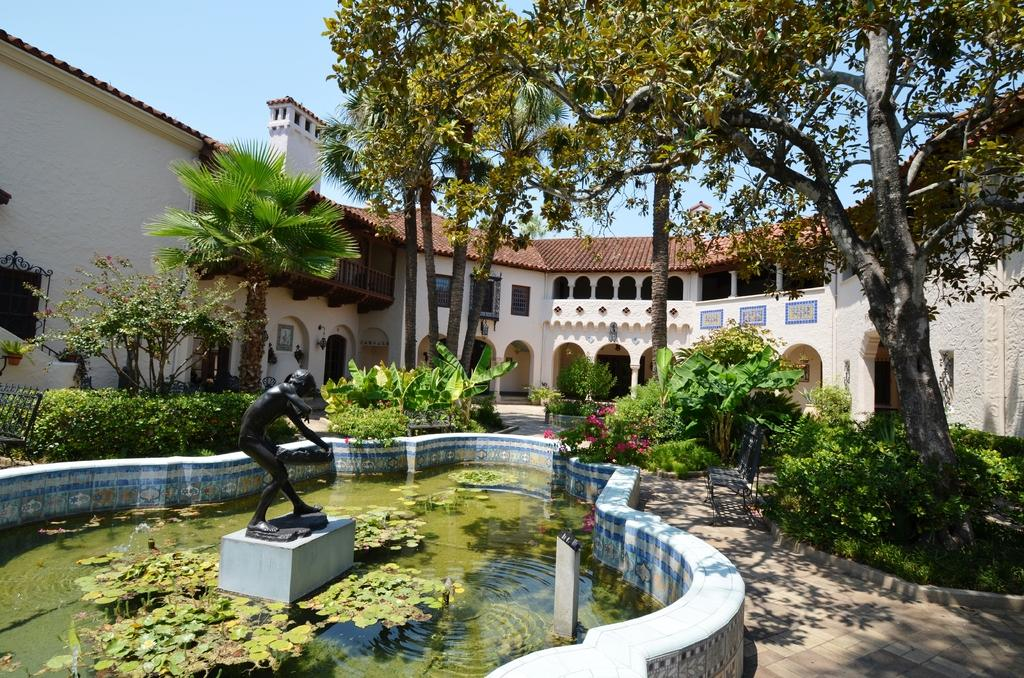What type of structure is visible in the image? There is a house in the image. What architectural features can be seen on the house? There are pillars, walls, windows, and railings visible on the house. What other objects or elements are present in the image? There are trees, plants, a bench, a statue, and water fountains in the image. What can be seen in the background of the image? The sky is visible in the background of the image. How many beds are visible in the image? There are no beds present in the image. What type of flame can be seen coming from the statue's finger in the image? There is no flame or statue with a finger in the image; the statue present does not have a finger. 